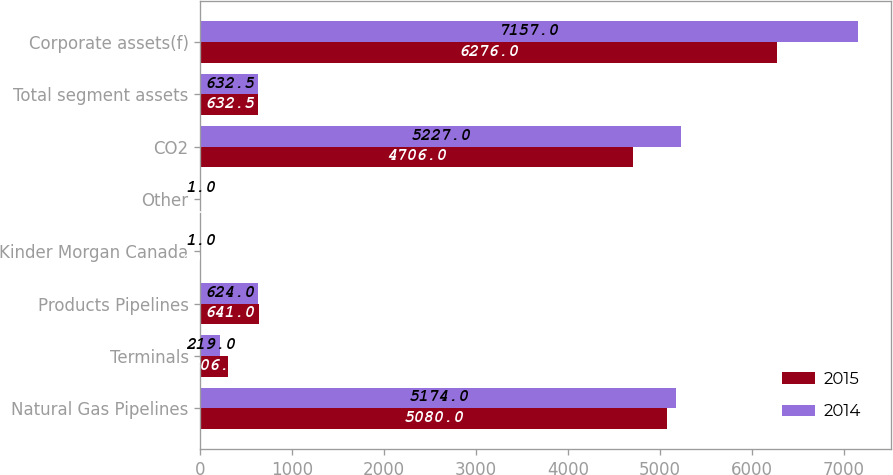Convert chart. <chart><loc_0><loc_0><loc_500><loc_500><stacked_bar_chart><ecel><fcel>Natural Gas Pipelines<fcel>Terminals<fcel>Products Pipelines<fcel>Kinder Morgan Canada<fcel>Other<fcel>CO2<fcel>Total segment assets<fcel>Corporate assets(f)<nl><fcel>2015<fcel>5080<fcel>306<fcel>641<fcel>10<fcel>3<fcel>4706<fcel>632.5<fcel>6276<nl><fcel>2014<fcel>5174<fcel>219<fcel>624<fcel>1<fcel>1<fcel>5227<fcel>632.5<fcel>7157<nl></chart> 